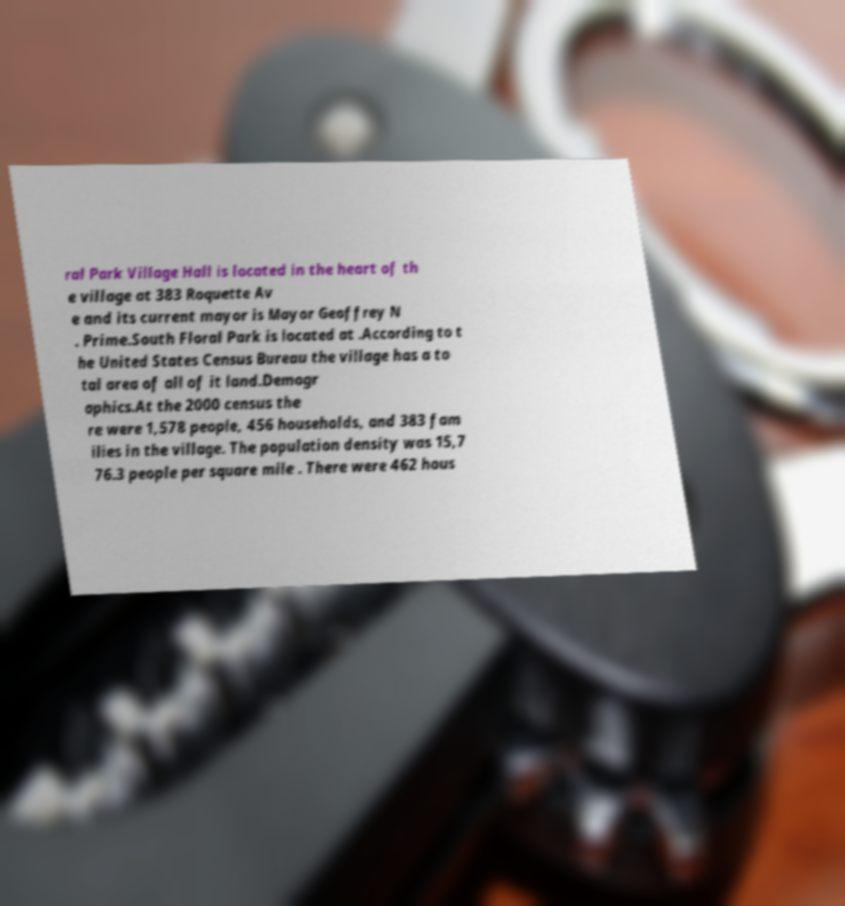Can you accurately transcribe the text from the provided image for me? ral Park Village Hall is located in the heart of th e village at 383 Roquette Av e and its current mayor is Mayor Geoffrey N . Prime.South Floral Park is located at .According to t he United States Census Bureau the village has a to tal area of all of it land.Demogr aphics.At the 2000 census the re were 1,578 people, 456 households, and 383 fam ilies in the village. The population density was 15,7 76.3 people per square mile . There were 462 hous 